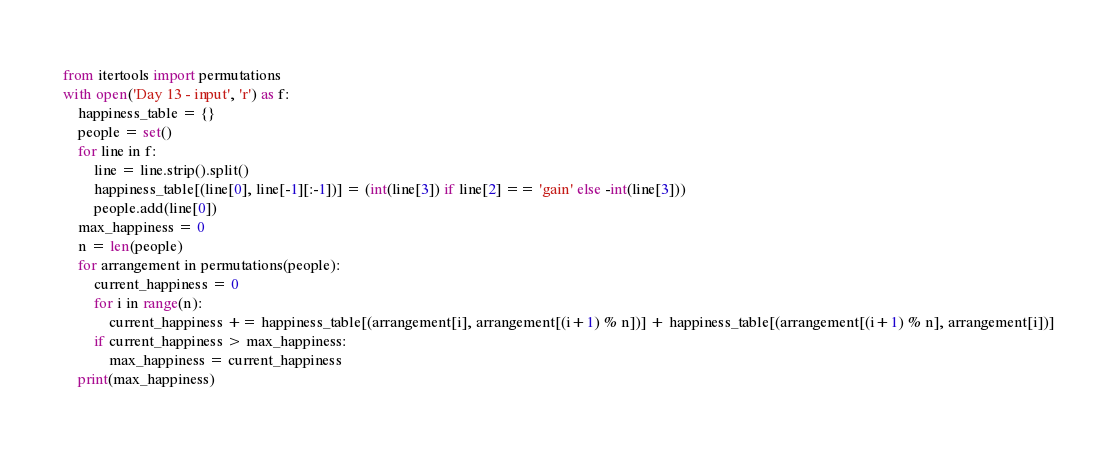Convert code to text. <code><loc_0><loc_0><loc_500><loc_500><_Python_>from itertools import permutations
with open('Day 13 - input', 'r') as f:
    happiness_table = {}
    people = set()
    for line in f:
        line = line.strip().split()
        happiness_table[(line[0], line[-1][:-1])] = (int(line[3]) if line[2] == 'gain' else -int(line[3]))
        people.add(line[0])
    max_happiness = 0
    n = len(people)
    for arrangement in permutations(people):
        current_happiness = 0
        for i in range(n):
            current_happiness += happiness_table[(arrangement[i], arrangement[(i+1) % n])] + happiness_table[(arrangement[(i+1) % n], arrangement[i])]
        if current_happiness > max_happiness:
            max_happiness = current_happiness
    print(max_happiness)</code> 